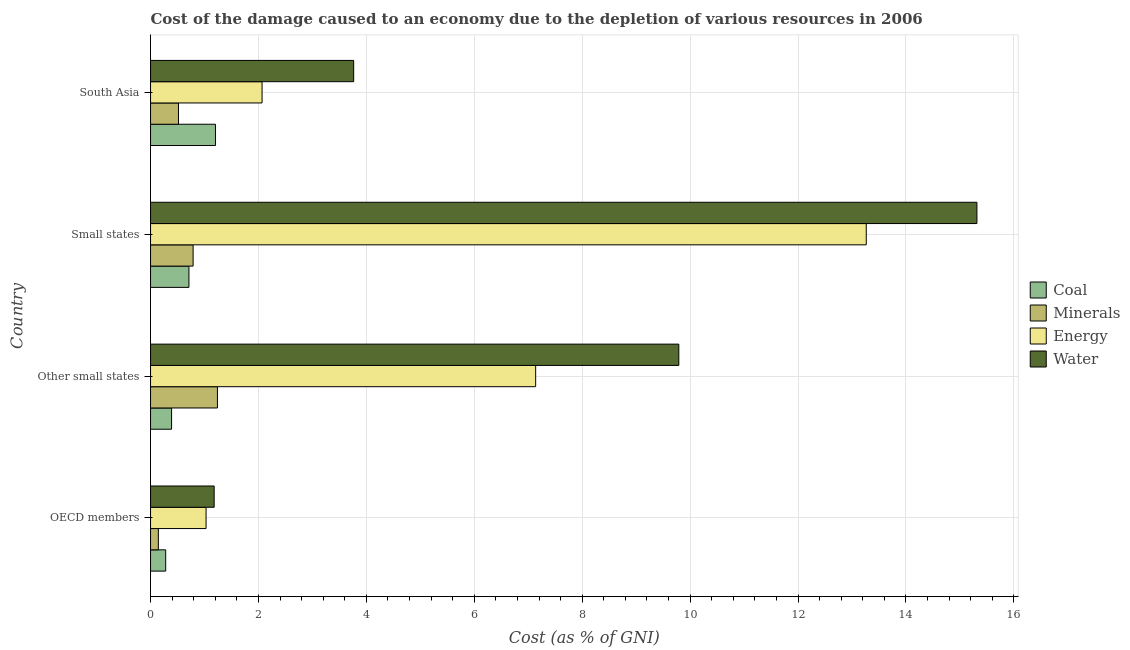How many groups of bars are there?
Offer a very short reply. 4. Are the number of bars on each tick of the Y-axis equal?
Your answer should be very brief. Yes. What is the label of the 3rd group of bars from the top?
Make the answer very short. Other small states. What is the cost of damage due to depletion of coal in Other small states?
Make the answer very short. 0.39. Across all countries, what is the maximum cost of damage due to depletion of water?
Keep it short and to the point. 15.32. Across all countries, what is the minimum cost of damage due to depletion of coal?
Keep it short and to the point. 0.28. In which country was the cost of damage due to depletion of coal maximum?
Make the answer very short. South Asia. What is the total cost of damage due to depletion of water in the graph?
Give a very brief answer. 30.05. What is the difference between the cost of damage due to depletion of minerals in OECD members and that in Other small states?
Your answer should be very brief. -1.09. What is the difference between the cost of damage due to depletion of water in OECD members and the cost of damage due to depletion of coal in Other small states?
Ensure brevity in your answer.  0.79. What is the average cost of damage due to depletion of coal per country?
Provide a succinct answer. 0.65. What is the difference between the cost of damage due to depletion of energy and cost of damage due to depletion of water in South Asia?
Provide a succinct answer. -1.7. In how many countries, is the cost of damage due to depletion of coal greater than 15.2 %?
Offer a terse response. 0. What is the ratio of the cost of damage due to depletion of energy in Other small states to that in Small states?
Your answer should be very brief. 0.54. Is the cost of damage due to depletion of energy in OECD members less than that in South Asia?
Offer a very short reply. Yes. Is the difference between the cost of damage due to depletion of coal in OECD members and Small states greater than the difference between the cost of damage due to depletion of minerals in OECD members and Small states?
Offer a very short reply. Yes. What is the difference between the highest and the second highest cost of damage due to depletion of coal?
Keep it short and to the point. 0.49. What is the difference between the highest and the lowest cost of damage due to depletion of energy?
Ensure brevity in your answer.  12.24. In how many countries, is the cost of damage due to depletion of coal greater than the average cost of damage due to depletion of coal taken over all countries?
Offer a terse response. 2. What does the 3rd bar from the top in Other small states represents?
Offer a terse response. Minerals. What does the 2nd bar from the bottom in South Asia represents?
Offer a terse response. Minerals. Is it the case that in every country, the sum of the cost of damage due to depletion of coal and cost of damage due to depletion of minerals is greater than the cost of damage due to depletion of energy?
Provide a succinct answer. No. Are the values on the major ticks of X-axis written in scientific E-notation?
Give a very brief answer. No. Does the graph contain grids?
Give a very brief answer. Yes. Where does the legend appear in the graph?
Offer a terse response. Center right. How many legend labels are there?
Give a very brief answer. 4. How are the legend labels stacked?
Offer a very short reply. Vertical. What is the title of the graph?
Ensure brevity in your answer.  Cost of the damage caused to an economy due to the depletion of various resources in 2006 . Does "Sweden" appear as one of the legend labels in the graph?
Give a very brief answer. No. What is the label or title of the X-axis?
Provide a succinct answer. Cost (as % of GNI). What is the label or title of the Y-axis?
Offer a very short reply. Country. What is the Cost (as % of GNI) of Coal in OECD members?
Your answer should be compact. 0.28. What is the Cost (as % of GNI) of Minerals in OECD members?
Your answer should be very brief. 0.14. What is the Cost (as % of GNI) in Energy in OECD members?
Keep it short and to the point. 1.03. What is the Cost (as % of GNI) of Water in OECD members?
Your answer should be compact. 1.18. What is the Cost (as % of GNI) of Coal in Other small states?
Your answer should be very brief. 0.39. What is the Cost (as % of GNI) of Minerals in Other small states?
Make the answer very short. 1.24. What is the Cost (as % of GNI) of Energy in Other small states?
Give a very brief answer. 7.14. What is the Cost (as % of GNI) in Water in Other small states?
Keep it short and to the point. 9.79. What is the Cost (as % of GNI) of Coal in Small states?
Ensure brevity in your answer.  0.71. What is the Cost (as % of GNI) of Minerals in Small states?
Offer a terse response. 0.79. What is the Cost (as % of GNI) of Energy in Small states?
Your answer should be very brief. 13.27. What is the Cost (as % of GNI) in Water in Small states?
Give a very brief answer. 15.32. What is the Cost (as % of GNI) of Coal in South Asia?
Provide a short and direct response. 1.2. What is the Cost (as % of GNI) in Minerals in South Asia?
Make the answer very short. 0.52. What is the Cost (as % of GNI) in Energy in South Asia?
Your answer should be very brief. 2.07. What is the Cost (as % of GNI) of Water in South Asia?
Ensure brevity in your answer.  3.76. Across all countries, what is the maximum Cost (as % of GNI) in Coal?
Offer a terse response. 1.2. Across all countries, what is the maximum Cost (as % of GNI) of Minerals?
Your answer should be very brief. 1.24. Across all countries, what is the maximum Cost (as % of GNI) of Energy?
Provide a short and direct response. 13.27. Across all countries, what is the maximum Cost (as % of GNI) in Water?
Your response must be concise. 15.32. Across all countries, what is the minimum Cost (as % of GNI) in Coal?
Offer a very short reply. 0.28. Across all countries, what is the minimum Cost (as % of GNI) in Minerals?
Offer a terse response. 0.14. Across all countries, what is the minimum Cost (as % of GNI) in Energy?
Offer a terse response. 1.03. Across all countries, what is the minimum Cost (as % of GNI) in Water?
Keep it short and to the point. 1.18. What is the total Cost (as % of GNI) of Coal in the graph?
Provide a succinct answer. 2.59. What is the total Cost (as % of GNI) of Minerals in the graph?
Your answer should be very brief. 2.69. What is the total Cost (as % of GNI) of Energy in the graph?
Your response must be concise. 23.5. What is the total Cost (as % of GNI) of Water in the graph?
Keep it short and to the point. 30.05. What is the difference between the Cost (as % of GNI) in Coal in OECD members and that in Other small states?
Offer a very short reply. -0.11. What is the difference between the Cost (as % of GNI) in Minerals in OECD members and that in Other small states?
Your response must be concise. -1.1. What is the difference between the Cost (as % of GNI) of Energy in OECD members and that in Other small states?
Keep it short and to the point. -6.11. What is the difference between the Cost (as % of GNI) in Water in OECD members and that in Other small states?
Ensure brevity in your answer.  -8.61. What is the difference between the Cost (as % of GNI) of Coal in OECD members and that in Small states?
Make the answer very short. -0.43. What is the difference between the Cost (as % of GNI) in Minerals in OECD members and that in Small states?
Give a very brief answer. -0.64. What is the difference between the Cost (as % of GNI) in Energy in OECD members and that in Small states?
Keep it short and to the point. -12.24. What is the difference between the Cost (as % of GNI) in Water in OECD members and that in Small states?
Provide a succinct answer. -14.14. What is the difference between the Cost (as % of GNI) of Coal in OECD members and that in South Asia?
Make the answer very short. -0.92. What is the difference between the Cost (as % of GNI) of Minerals in OECD members and that in South Asia?
Your answer should be very brief. -0.37. What is the difference between the Cost (as % of GNI) in Energy in OECD members and that in South Asia?
Your response must be concise. -1.04. What is the difference between the Cost (as % of GNI) in Water in OECD members and that in South Asia?
Offer a terse response. -2.59. What is the difference between the Cost (as % of GNI) of Coal in Other small states and that in Small states?
Keep it short and to the point. -0.32. What is the difference between the Cost (as % of GNI) in Minerals in Other small states and that in Small states?
Offer a terse response. 0.45. What is the difference between the Cost (as % of GNI) in Energy in Other small states and that in Small states?
Your response must be concise. -6.13. What is the difference between the Cost (as % of GNI) in Water in Other small states and that in Small states?
Give a very brief answer. -5.53. What is the difference between the Cost (as % of GNI) in Coal in Other small states and that in South Asia?
Provide a short and direct response. -0.81. What is the difference between the Cost (as % of GNI) of Minerals in Other small states and that in South Asia?
Offer a very short reply. 0.72. What is the difference between the Cost (as % of GNI) of Energy in Other small states and that in South Asia?
Provide a short and direct response. 5.07. What is the difference between the Cost (as % of GNI) of Water in Other small states and that in South Asia?
Offer a terse response. 6.03. What is the difference between the Cost (as % of GNI) of Coal in Small states and that in South Asia?
Offer a very short reply. -0.49. What is the difference between the Cost (as % of GNI) of Minerals in Small states and that in South Asia?
Your answer should be compact. 0.27. What is the difference between the Cost (as % of GNI) of Energy in Small states and that in South Asia?
Ensure brevity in your answer.  11.2. What is the difference between the Cost (as % of GNI) of Water in Small states and that in South Asia?
Provide a succinct answer. 11.55. What is the difference between the Cost (as % of GNI) in Coal in OECD members and the Cost (as % of GNI) in Minerals in Other small states?
Provide a short and direct response. -0.96. What is the difference between the Cost (as % of GNI) of Coal in OECD members and the Cost (as % of GNI) of Energy in Other small states?
Offer a very short reply. -6.86. What is the difference between the Cost (as % of GNI) in Coal in OECD members and the Cost (as % of GNI) in Water in Other small states?
Your answer should be very brief. -9.51. What is the difference between the Cost (as % of GNI) in Minerals in OECD members and the Cost (as % of GNI) in Energy in Other small states?
Your answer should be very brief. -6.99. What is the difference between the Cost (as % of GNI) in Minerals in OECD members and the Cost (as % of GNI) in Water in Other small states?
Keep it short and to the point. -9.65. What is the difference between the Cost (as % of GNI) of Energy in OECD members and the Cost (as % of GNI) of Water in Other small states?
Ensure brevity in your answer.  -8.76. What is the difference between the Cost (as % of GNI) in Coal in OECD members and the Cost (as % of GNI) in Minerals in Small states?
Give a very brief answer. -0.51. What is the difference between the Cost (as % of GNI) of Coal in OECD members and the Cost (as % of GNI) of Energy in Small states?
Make the answer very short. -12.98. What is the difference between the Cost (as % of GNI) of Coal in OECD members and the Cost (as % of GNI) of Water in Small states?
Make the answer very short. -15.04. What is the difference between the Cost (as % of GNI) in Minerals in OECD members and the Cost (as % of GNI) in Energy in Small states?
Offer a terse response. -13.12. What is the difference between the Cost (as % of GNI) in Minerals in OECD members and the Cost (as % of GNI) in Water in Small states?
Provide a short and direct response. -15.17. What is the difference between the Cost (as % of GNI) of Energy in OECD members and the Cost (as % of GNI) of Water in Small states?
Offer a terse response. -14.29. What is the difference between the Cost (as % of GNI) of Coal in OECD members and the Cost (as % of GNI) of Minerals in South Asia?
Make the answer very short. -0.24. What is the difference between the Cost (as % of GNI) in Coal in OECD members and the Cost (as % of GNI) in Energy in South Asia?
Your answer should be compact. -1.79. What is the difference between the Cost (as % of GNI) of Coal in OECD members and the Cost (as % of GNI) of Water in South Asia?
Make the answer very short. -3.48. What is the difference between the Cost (as % of GNI) of Minerals in OECD members and the Cost (as % of GNI) of Energy in South Asia?
Make the answer very short. -1.92. What is the difference between the Cost (as % of GNI) in Minerals in OECD members and the Cost (as % of GNI) in Water in South Asia?
Provide a short and direct response. -3.62. What is the difference between the Cost (as % of GNI) of Energy in OECD members and the Cost (as % of GNI) of Water in South Asia?
Offer a very short reply. -2.74. What is the difference between the Cost (as % of GNI) of Coal in Other small states and the Cost (as % of GNI) of Minerals in Small states?
Keep it short and to the point. -0.4. What is the difference between the Cost (as % of GNI) of Coal in Other small states and the Cost (as % of GNI) of Energy in Small states?
Offer a very short reply. -12.88. What is the difference between the Cost (as % of GNI) of Coal in Other small states and the Cost (as % of GNI) of Water in Small states?
Provide a short and direct response. -14.93. What is the difference between the Cost (as % of GNI) of Minerals in Other small states and the Cost (as % of GNI) of Energy in Small states?
Make the answer very short. -12.03. What is the difference between the Cost (as % of GNI) in Minerals in Other small states and the Cost (as % of GNI) in Water in Small states?
Give a very brief answer. -14.08. What is the difference between the Cost (as % of GNI) of Energy in Other small states and the Cost (as % of GNI) of Water in Small states?
Ensure brevity in your answer.  -8.18. What is the difference between the Cost (as % of GNI) in Coal in Other small states and the Cost (as % of GNI) in Minerals in South Asia?
Provide a short and direct response. -0.13. What is the difference between the Cost (as % of GNI) of Coal in Other small states and the Cost (as % of GNI) of Energy in South Asia?
Make the answer very short. -1.68. What is the difference between the Cost (as % of GNI) of Coal in Other small states and the Cost (as % of GNI) of Water in South Asia?
Your answer should be compact. -3.38. What is the difference between the Cost (as % of GNI) of Minerals in Other small states and the Cost (as % of GNI) of Energy in South Asia?
Offer a very short reply. -0.83. What is the difference between the Cost (as % of GNI) of Minerals in Other small states and the Cost (as % of GNI) of Water in South Asia?
Give a very brief answer. -2.53. What is the difference between the Cost (as % of GNI) of Energy in Other small states and the Cost (as % of GNI) of Water in South Asia?
Give a very brief answer. 3.37. What is the difference between the Cost (as % of GNI) in Coal in Small states and the Cost (as % of GNI) in Minerals in South Asia?
Your answer should be compact. 0.19. What is the difference between the Cost (as % of GNI) of Coal in Small states and the Cost (as % of GNI) of Energy in South Asia?
Make the answer very short. -1.36. What is the difference between the Cost (as % of GNI) of Coal in Small states and the Cost (as % of GNI) of Water in South Asia?
Give a very brief answer. -3.05. What is the difference between the Cost (as % of GNI) in Minerals in Small states and the Cost (as % of GNI) in Energy in South Asia?
Ensure brevity in your answer.  -1.28. What is the difference between the Cost (as % of GNI) of Minerals in Small states and the Cost (as % of GNI) of Water in South Asia?
Keep it short and to the point. -2.98. What is the difference between the Cost (as % of GNI) of Energy in Small states and the Cost (as % of GNI) of Water in South Asia?
Provide a succinct answer. 9.5. What is the average Cost (as % of GNI) of Coal per country?
Keep it short and to the point. 0.65. What is the average Cost (as % of GNI) of Minerals per country?
Offer a very short reply. 0.67. What is the average Cost (as % of GNI) in Energy per country?
Make the answer very short. 5.87. What is the average Cost (as % of GNI) in Water per country?
Offer a very short reply. 7.51. What is the difference between the Cost (as % of GNI) of Coal and Cost (as % of GNI) of Minerals in OECD members?
Give a very brief answer. 0.14. What is the difference between the Cost (as % of GNI) of Coal and Cost (as % of GNI) of Energy in OECD members?
Offer a terse response. -0.75. What is the difference between the Cost (as % of GNI) of Coal and Cost (as % of GNI) of Water in OECD members?
Provide a succinct answer. -0.9. What is the difference between the Cost (as % of GNI) in Minerals and Cost (as % of GNI) in Energy in OECD members?
Offer a very short reply. -0.88. What is the difference between the Cost (as % of GNI) of Minerals and Cost (as % of GNI) of Water in OECD members?
Keep it short and to the point. -1.03. What is the difference between the Cost (as % of GNI) in Energy and Cost (as % of GNI) in Water in OECD members?
Offer a terse response. -0.15. What is the difference between the Cost (as % of GNI) in Coal and Cost (as % of GNI) in Minerals in Other small states?
Provide a short and direct response. -0.85. What is the difference between the Cost (as % of GNI) in Coal and Cost (as % of GNI) in Energy in Other small states?
Make the answer very short. -6.75. What is the difference between the Cost (as % of GNI) in Coal and Cost (as % of GNI) in Water in Other small states?
Offer a very short reply. -9.4. What is the difference between the Cost (as % of GNI) in Minerals and Cost (as % of GNI) in Energy in Other small states?
Your response must be concise. -5.9. What is the difference between the Cost (as % of GNI) in Minerals and Cost (as % of GNI) in Water in Other small states?
Offer a terse response. -8.55. What is the difference between the Cost (as % of GNI) in Energy and Cost (as % of GNI) in Water in Other small states?
Make the answer very short. -2.65. What is the difference between the Cost (as % of GNI) in Coal and Cost (as % of GNI) in Minerals in Small states?
Offer a terse response. -0.08. What is the difference between the Cost (as % of GNI) of Coal and Cost (as % of GNI) of Energy in Small states?
Offer a terse response. -12.55. What is the difference between the Cost (as % of GNI) in Coal and Cost (as % of GNI) in Water in Small states?
Offer a very short reply. -14.6. What is the difference between the Cost (as % of GNI) in Minerals and Cost (as % of GNI) in Energy in Small states?
Make the answer very short. -12.48. What is the difference between the Cost (as % of GNI) of Minerals and Cost (as % of GNI) of Water in Small states?
Give a very brief answer. -14.53. What is the difference between the Cost (as % of GNI) of Energy and Cost (as % of GNI) of Water in Small states?
Provide a short and direct response. -2.05. What is the difference between the Cost (as % of GNI) in Coal and Cost (as % of GNI) in Minerals in South Asia?
Make the answer very short. 0.69. What is the difference between the Cost (as % of GNI) in Coal and Cost (as % of GNI) in Energy in South Asia?
Provide a succinct answer. -0.86. What is the difference between the Cost (as % of GNI) of Coal and Cost (as % of GNI) of Water in South Asia?
Ensure brevity in your answer.  -2.56. What is the difference between the Cost (as % of GNI) of Minerals and Cost (as % of GNI) of Energy in South Asia?
Offer a very short reply. -1.55. What is the difference between the Cost (as % of GNI) in Minerals and Cost (as % of GNI) in Water in South Asia?
Offer a terse response. -3.25. What is the difference between the Cost (as % of GNI) in Energy and Cost (as % of GNI) in Water in South Asia?
Your answer should be very brief. -1.7. What is the ratio of the Cost (as % of GNI) in Coal in OECD members to that in Other small states?
Your answer should be compact. 0.72. What is the ratio of the Cost (as % of GNI) in Minerals in OECD members to that in Other small states?
Your answer should be very brief. 0.12. What is the ratio of the Cost (as % of GNI) of Energy in OECD members to that in Other small states?
Give a very brief answer. 0.14. What is the ratio of the Cost (as % of GNI) of Water in OECD members to that in Other small states?
Ensure brevity in your answer.  0.12. What is the ratio of the Cost (as % of GNI) of Coal in OECD members to that in Small states?
Your answer should be very brief. 0.4. What is the ratio of the Cost (as % of GNI) in Minerals in OECD members to that in Small states?
Your answer should be compact. 0.18. What is the ratio of the Cost (as % of GNI) of Energy in OECD members to that in Small states?
Your response must be concise. 0.08. What is the ratio of the Cost (as % of GNI) in Water in OECD members to that in Small states?
Ensure brevity in your answer.  0.08. What is the ratio of the Cost (as % of GNI) of Coal in OECD members to that in South Asia?
Provide a succinct answer. 0.23. What is the ratio of the Cost (as % of GNI) in Minerals in OECD members to that in South Asia?
Provide a succinct answer. 0.28. What is the ratio of the Cost (as % of GNI) of Energy in OECD members to that in South Asia?
Keep it short and to the point. 0.5. What is the ratio of the Cost (as % of GNI) of Water in OECD members to that in South Asia?
Make the answer very short. 0.31. What is the ratio of the Cost (as % of GNI) in Coal in Other small states to that in Small states?
Make the answer very short. 0.55. What is the ratio of the Cost (as % of GNI) in Minerals in Other small states to that in Small states?
Provide a short and direct response. 1.57. What is the ratio of the Cost (as % of GNI) in Energy in Other small states to that in Small states?
Provide a succinct answer. 0.54. What is the ratio of the Cost (as % of GNI) of Water in Other small states to that in Small states?
Your answer should be compact. 0.64. What is the ratio of the Cost (as % of GNI) of Coal in Other small states to that in South Asia?
Your answer should be very brief. 0.32. What is the ratio of the Cost (as % of GNI) of Minerals in Other small states to that in South Asia?
Offer a terse response. 2.39. What is the ratio of the Cost (as % of GNI) of Energy in Other small states to that in South Asia?
Give a very brief answer. 3.45. What is the ratio of the Cost (as % of GNI) in Water in Other small states to that in South Asia?
Provide a succinct answer. 2.6. What is the ratio of the Cost (as % of GNI) of Coal in Small states to that in South Asia?
Your response must be concise. 0.59. What is the ratio of the Cost (as % of GNI) in Minerals in Small states to that in South Asia?
Give a very brief answer. 1.52. What is the ratio of the Cost (as % of GNI) of Energy in Small states to that in South Asia?
Your answer should be very brief. 6.42. What is the ratio of the Cost (as % of GNI) in Water in Small states to that in South Asia?
Your answer should be very brief. 4.07. What is the difference between the highest and the second highest Cost (as % of GNI) in Coal?
Offer a terse response. 0.49. What is the difference between the highest and the second highest Cost (as % of GNI) of Minerals?
Give a very brief answer. 0.45. What is the difference between the highest and the second highest Cost (as % of GNI) of Energy?
Make the answer very short. 6.13. What is the difference between the highest and the second highest Cost (as % of GNI) of Water?
Give a very brief answer. 5.53. What is the difference between the highest and the lowest Cost (as % of GNI) in Coal?
Your answer should be very brief. 0.92. What is the difference between the highest and the lowest Cost (as % of GNI) in Minerals?
Ensure brevity in your answer.  1.1. What is the difference between the highest and the lowest Cost (as % of GNI) of Energy?
Provide a short and direct response. 12.24. What is the difference between the highest and the lowest Cost (as % of GNI) in Water?
Your response must be concise. 14.14. 